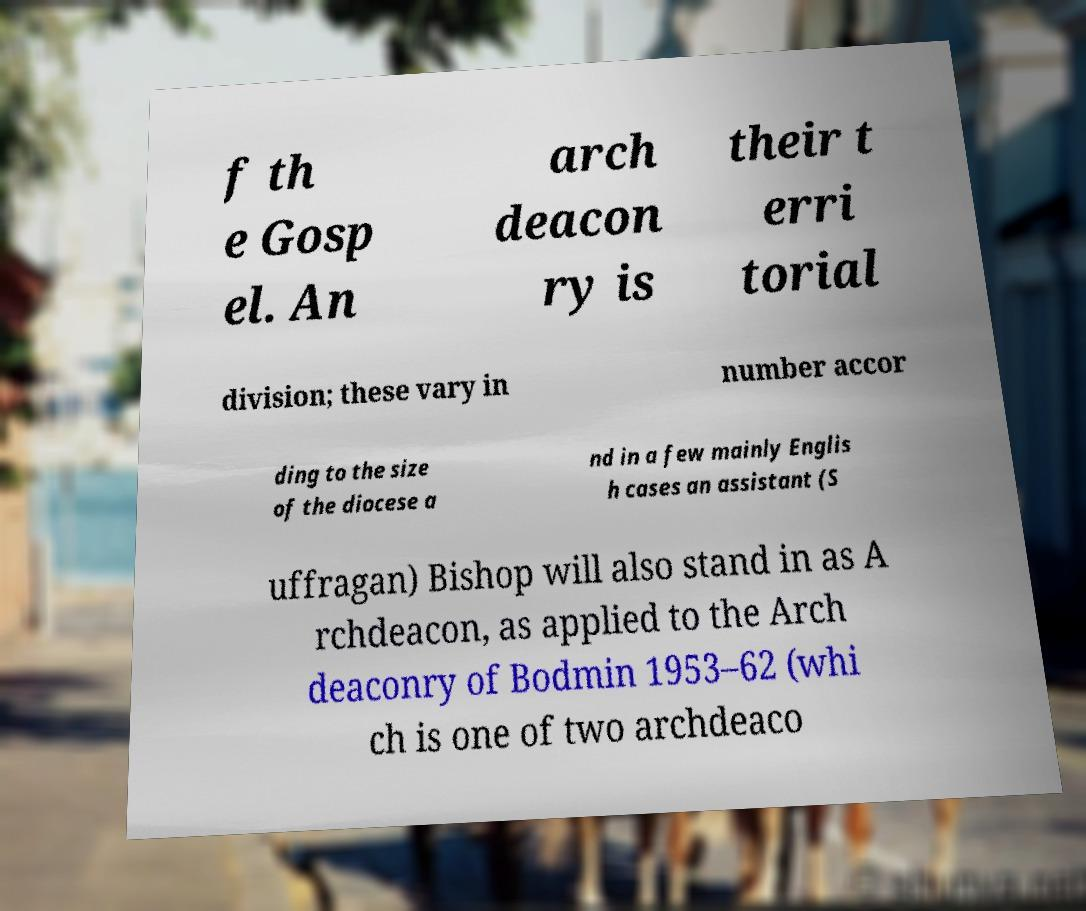Please read and relay the text visible in this image. What does it say? f th e Gosp el. An arch deacon ry is their t erri torial division; these vary in number accor ding to the size of the diocese a nd in a few mainly Englis h cases an assistant (S uffragan) Bishop will also stand in as A rchdeacon, as applied to the Arch deaconry of Bodmin 1953–62 (whi ch is one of two archdeaco 